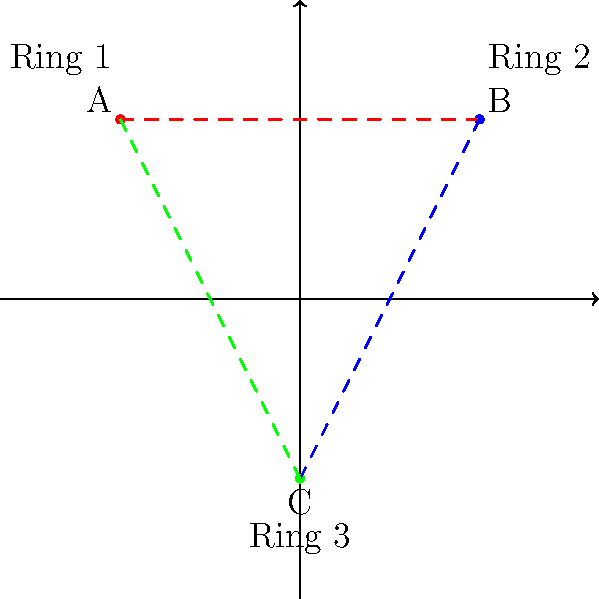In a multi-ring wrestling event, three wrestlers (A, B, and C) are planning their entrances and exits. The coordinate system represents the arena layout with three rings. Wrestler A starts at Ring 1 (-3, 3), moves to Ring 2 (3, 3), then to Ring 3 (0, -3), and finally back to Ring 1. Calculate the total distance traveled by Wrestler A, assuming they move in straight lines between rings. To solve this problem, we'll follow these steps:

1. Identify the coordinates of each ring:
   Ring 1: (-3, 3)
   Ring 2: (3, 3)
   Ring 3: (0, -3)

2. Calculate the distance between each pair of points using the distance formula:
   $d = \sqrt{(x_2 - x_1)^2 + (y_2 - y_1)^2}$

3. From Ring 1 to Ring 2:
   $d_1 = \sqrt{(3 - (-3))^2 + (3 - 3)^2} = \sqrt{36 + 0} = 6$

4. From Ring 2 to Ring 3:
   $d_2 = \sqrt{(0 - 3)^2 + (-3 - 3)^2} = \sqrt{9 + 36} = \sqrt{45} = 3\sqrt{5}$

5. From Ring 3 back to Ring 1:
   $d_3 = \sqrt{(-3 - 0)^2 + (3 - (-3))^2} = \sqrt{9 + 36} = \sqrt{45} = 3\sqrt{5}$

6. Sum up all distances:
   Total distance = $d_1 + d_2 + d_3 = 6 + 3\sqrt{5} + 3\sqrt{5} = 6 + 6\sqrt{5}$

Therefore, the total distance traveled by Wrestler A is $6 + 6\sqrt{5}$ units.
Answer: $6 + 6\sqrt{5}$ units 